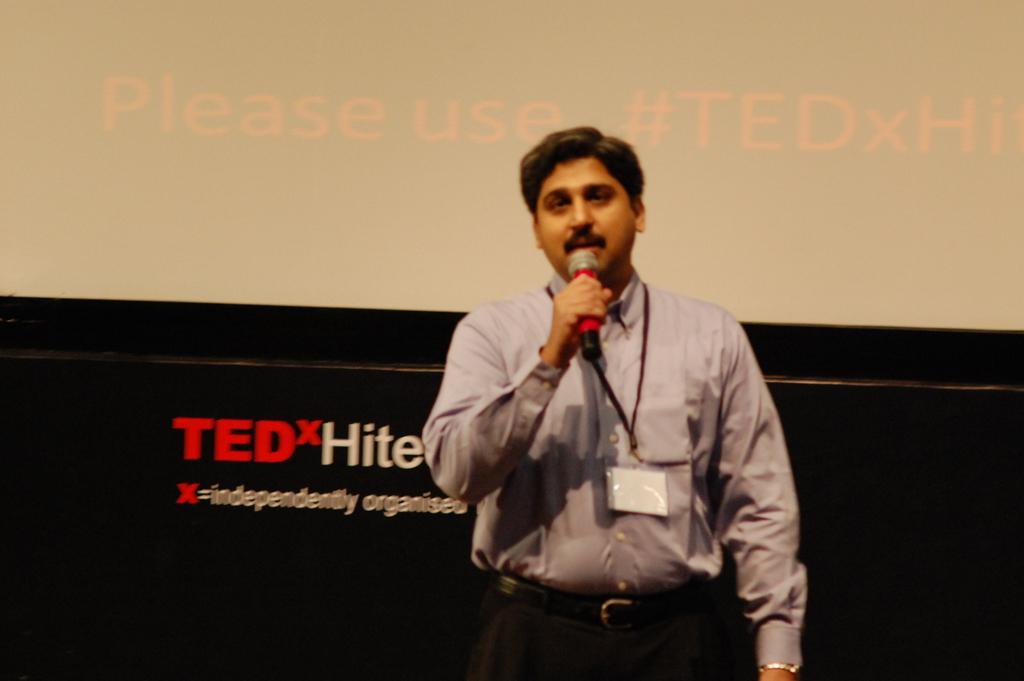Please provide a concise description of this image. There is a man standing on the stage wearing an ID card and holding a microphone in his hand. He is talking. In the background we can see a screen here. 